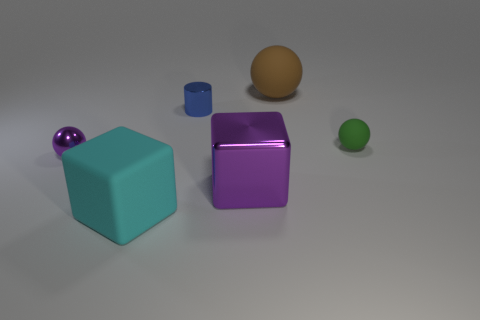Is there anything else that is the same shape as the blue metal thing?
Your answer should be compact. No. There is a green object that is the same shape as the big brown thing; what is its size?
Ensure brevity in your answer.  Small. Are there more purple balls in front of the small purple shiny thing than small blue metallic cylinders?
Your answer should be very brief. No. Is the material of the tiny purple object the same as the big brown thing?
Ensure brevity in your answer.  No. How many objects are balls on the left side of the purple metallic cube or matte objects that are left of the tiny matte sphere?
Make the answer very short. 3. What is the color of the other matte thing that is the same shape as the large brown rubber object?
Provide a succinct answer. Green. How many tiny metal things have the same color as the big metal cube?
Offer a very short reply. 1. Is the metal ball the same color as the small matte ball?
Ensure brevity in your answer.  No. How many things are either purple objects that are to the left of the brown object or tiny blue shiny cylinders?
Give a very brief answer. 3. What is the color of the matte thing on the left side of the metal thing behind the thing that is right of the brown matte sphere?
Provide a short and direct response. Cyan. 